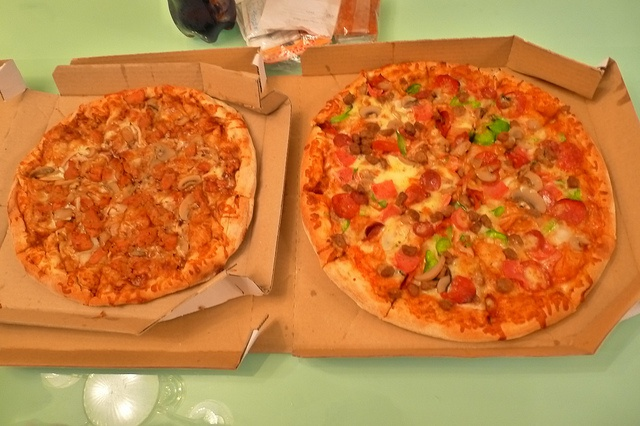Describe the objects in this image and their specific colors. I can see pizza in khaki, red, orange, and brown tones, dining table in khaki and tan tones, and pizza in khaki, red, brown, and orange tones in this image. 